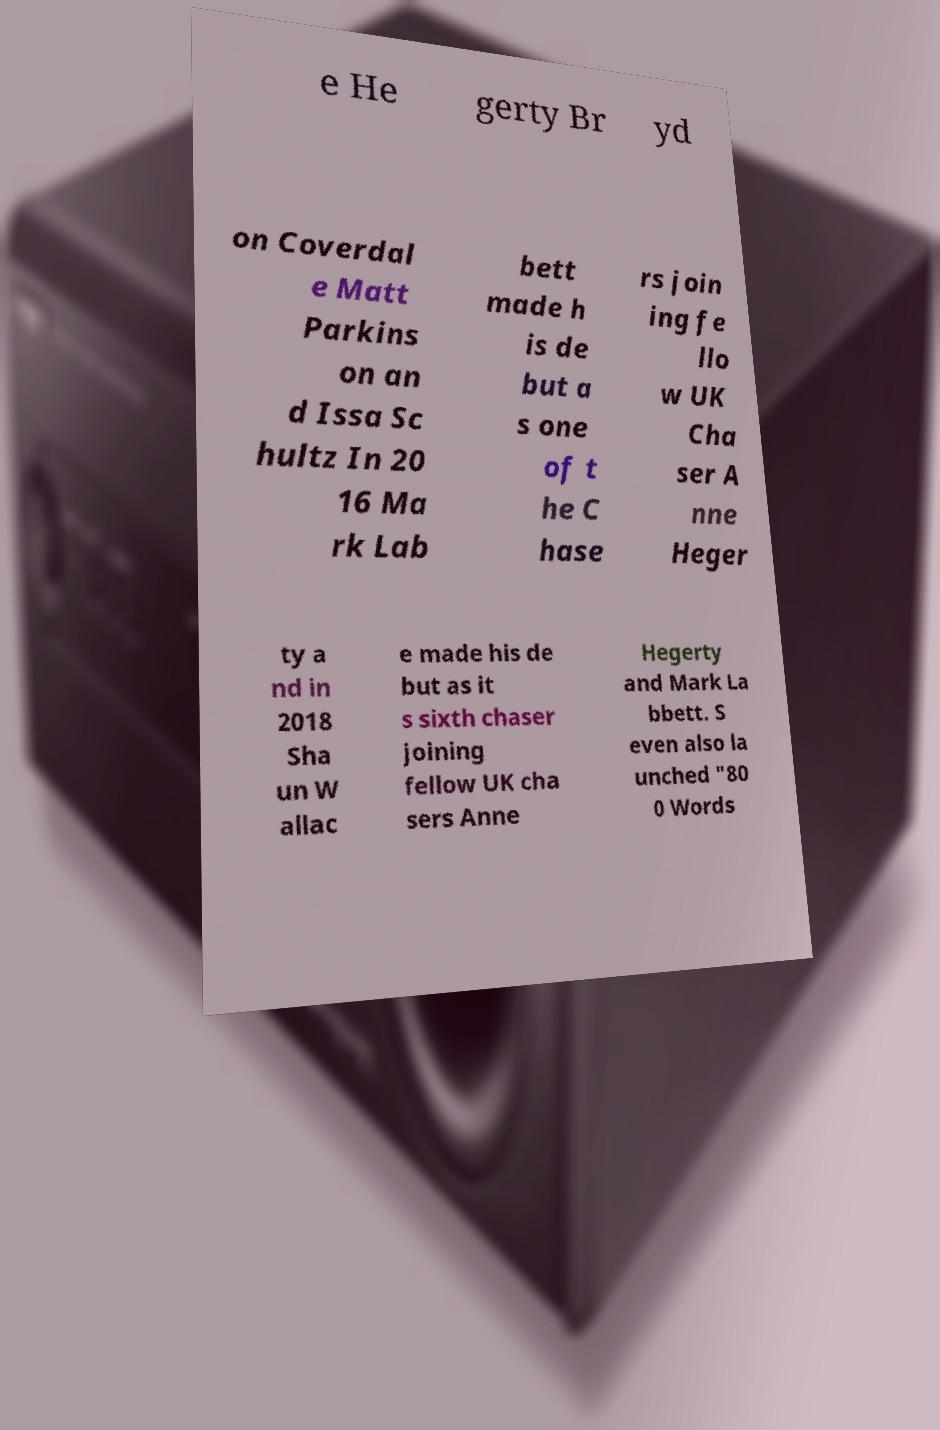Please read and relay the text visible in this image. What does it say? e He gerty Br yd on Coverdal e Matt Parkins on an d Issa Sc hultz In 20 16 Ma rk Lab bett made h is de but a s one of t he C hase rs join ing fe llo w UK Cha ser A nne Heger ty a nd in 2018 Sha un W allac e made his de but as it s sixth chaser joining fellow UK cha sers Anne Hegerty and Mark La bbett. S even also la unched "80 0 Words 